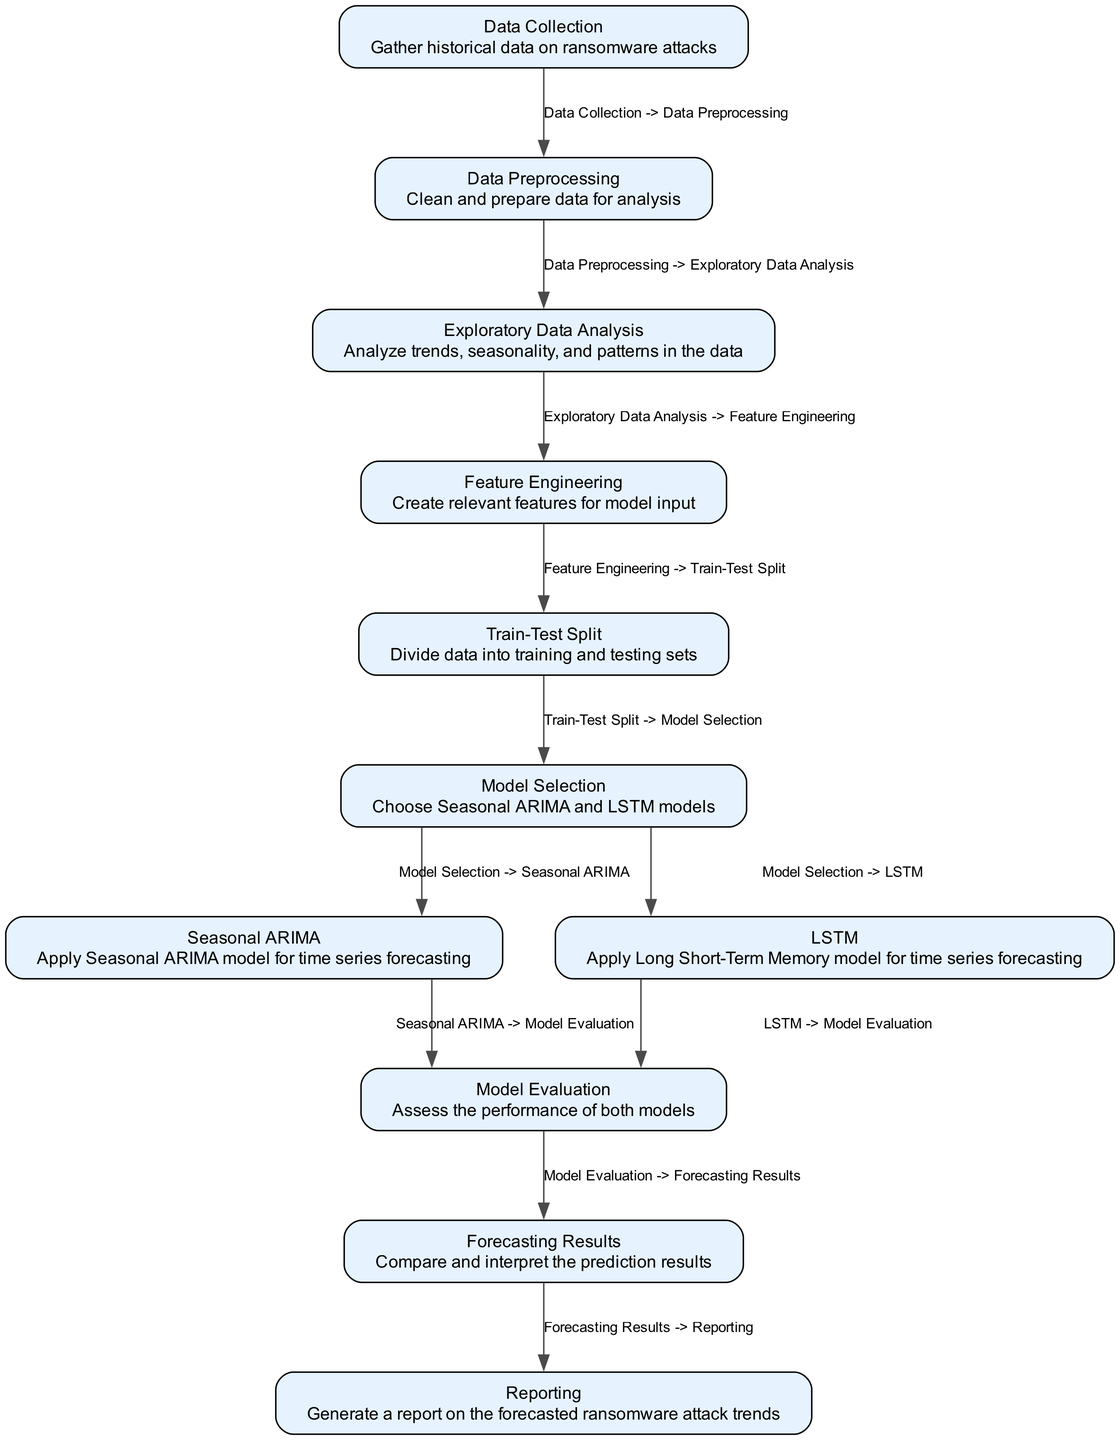What is the first node in the diagram? The diagram starts with "Data Collection" as the first node, which is the initial step in the workflow.
Answer: Data Collection How many nodes are there in total? By counting the individual nodes in the diagram, there are eleven nodes listed that represent each stage of the process.
Answer: Eleven What follows after "Data Preprocessing"? The next step after "Data Preprocessing" is "Exploratory Data Analysis," indicating the sequence in the workflow.
Answer: Exploratory Data Analysis Which models are selected in the "Model Selection" node? In the "Model Selection" node, two models are mentioned: Seasonal ARIMA and LSTM, which are the chosen approaches for forecasting.
Answer: Seasonal ARIMA and LSTM What is the last node in the diagram? The final node in the diagram is "Reporting," which represents the ultimate goal of the process, summarizing the findings.
Answer: Reporting What is the relationship between "Train-Test Split" and "Model Selection"? "Train-Test Split" leads directly to "Model Selection," indicating that after splitting the data, the next step is to choose the appropriate models for analysis.
Answer: Directly connected Which node precedes "Model Evaluation"? Both "Seasonal ARIMA" and "LSTM" precede "Model Evaluation," as both models’ performances are evaluated at this stage.
Answer: Seasonal ARIMA and LSTM What is being generated in the "Reporting" node? The "Reporting" node involves the generation of a report on the forecasted ransomware attack trends based on the analysis conducted earlier.
Answer: A report on forecasted ransomware attack trends How are the models introduced in the diagram? The diagram presents the models after the “Model Selection” node, where "Seasonal ARIMA" and "LSTM" are introduced for forecasting purposes.
Answer: After Model Selection 